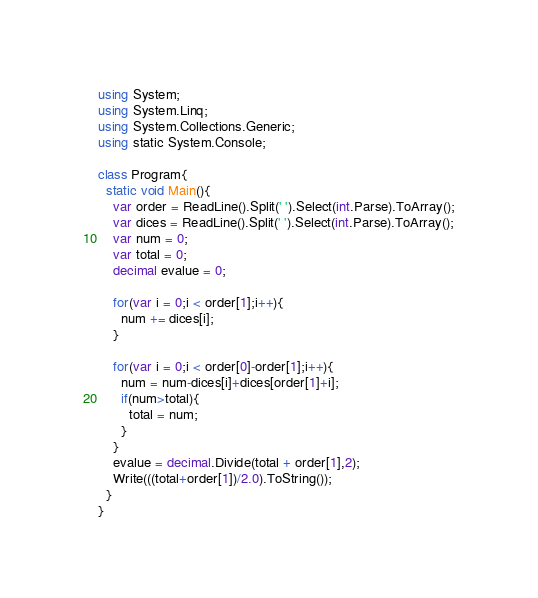Convert code to text. <code><loc_0><loc_0><loc_500><loc_500><_C#_>using System;
using System.Linq;
using System.Collections.Generic;
using static System.Console;

class Program{
  static void Main(){
	var order = ReadLine().Split(' ').Select(int.Parse).ToArray();
    var dices = ReadLine().Split(' ').Select(int.Parse).ToArray();
    var num = 0;
    var total = 0;
    decimal evalue = 0;
    
    for(var i = 0;i < order[1];i++){
      num += dices[i];
    }
    
    for(var i = 0;i < order[0]-order[1];i++){
      num = num-dices[i]+dices[order[1]+i];
      if(num>total){
        total = num;
      }
    }
    evalue = decimal.Divide(total + order[1],2);
    Write(((total+order[1])/2.0).ToString());
  }
}

</code> 